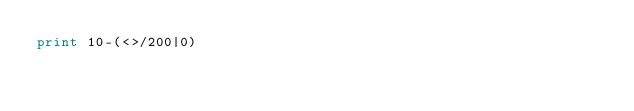Convert code to text. <code><loc_0><loc_0><loc_500><loc_500><_Perl_>print 10-(<>/200|0)</code> 